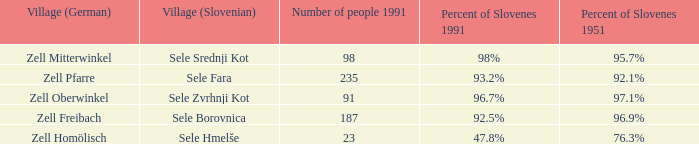Provide me with the name of all the village (German) that are part of the village (Slovenian) with sele srednji kot.  Zell Mitterwinkel. 